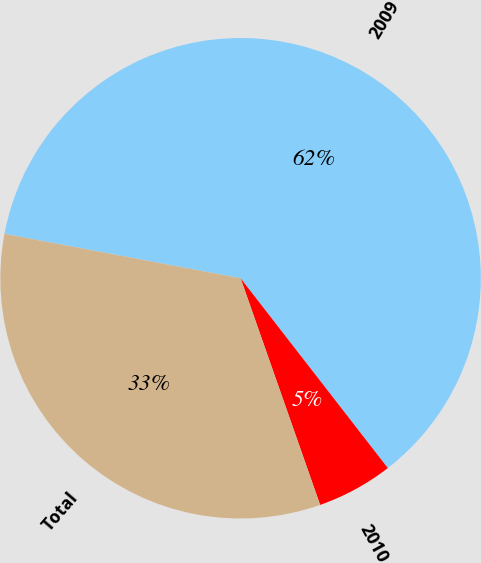Convert chart. <chart><loc_0><loc_0><loc_500><loc_500><pie_chart><fcel>2009<fcel>2010<fcel>Total<nl><fcel>61.54%<fcel>5.13%<fcel>33.33%<nl></chart> 